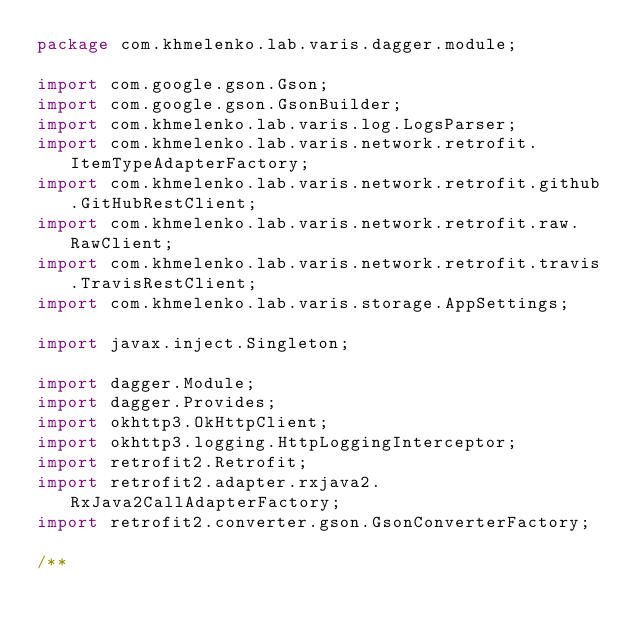<code> <loc_0><loc_0><loc_500><loc_500><_Java_>package com.khmelenko.lab.varis.dagger.module;

import com.google.gson.Gson;
import com.google.gson.GsonBuilder;
import com.khmelenko.lab.varis.log.LogsParser;
import com.khmelenko.lab.varis.network.retrofit.ItemTypeAdapterFactory;
import com.khmelenko.lab.varis.network.retrofit.github.GitHubRestClient;
import com.khmelenko.lab.varis.network.retrofit.raw.RawClient;
import com.khmelenko.lab.varis.network.retrofit.travis.TravisRestClient;
import com.khmelenko.lab.varis.storage.AppSettings;

import javax.inject.Singleton;

import dagger.Module;
import dagger.Provides;
import okhttp3.OkHttpClient;
import okhttp3.logging.HttpLoggingInterceptor;
import retrofit2.Retrofit;
import retrofit2.adapter.rxjava2.RxJava2CallAdapterFactory;
import retrofit2.converter.gson.GsonConverterFactory;

/**</code> 